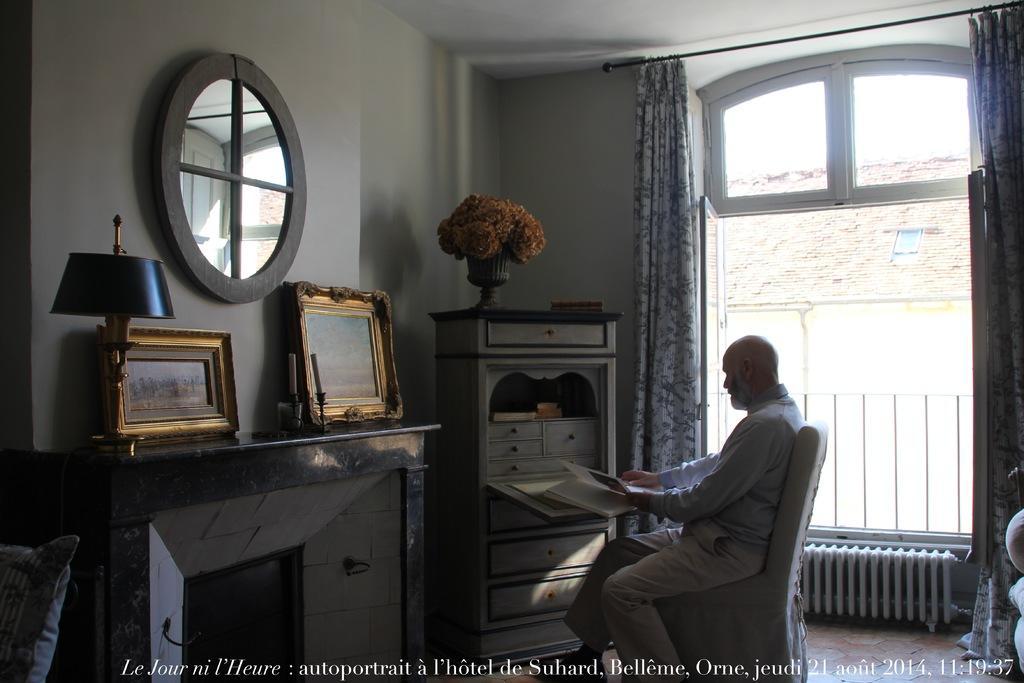Can you describe this image briefly? This is an inside view. Here I can see a man sitting on the chair and looking into the books. In front of this person there is a table. Beside that there is another bid table, on that two frames are placed. On the right side there is a window through that we can see the outside view and it is having the curtains on the both sides. To the left side wall a mirror is attached. 